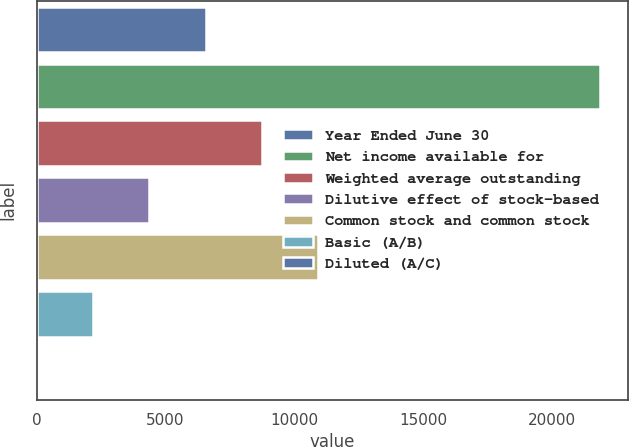Convert chart to OTSL. <chart><loc_0><loc_0><loc_500><loc_500><bar_chart><fcel>Year Ended June 30<fcel>Net income available for<fcel>Weighted average outstanding<fcel>Dilutive effect of stock-based<fcel>Common stock and common stock<fcel>Basic (A/B)<fcel>Diluted (A/C)<nl><fcel>6560.7<fcel>21863<fcel>8746.74<fcel>4374.66<fcel>10932.8<fcel>2188.62<fcel>2.58<nl></chart> 